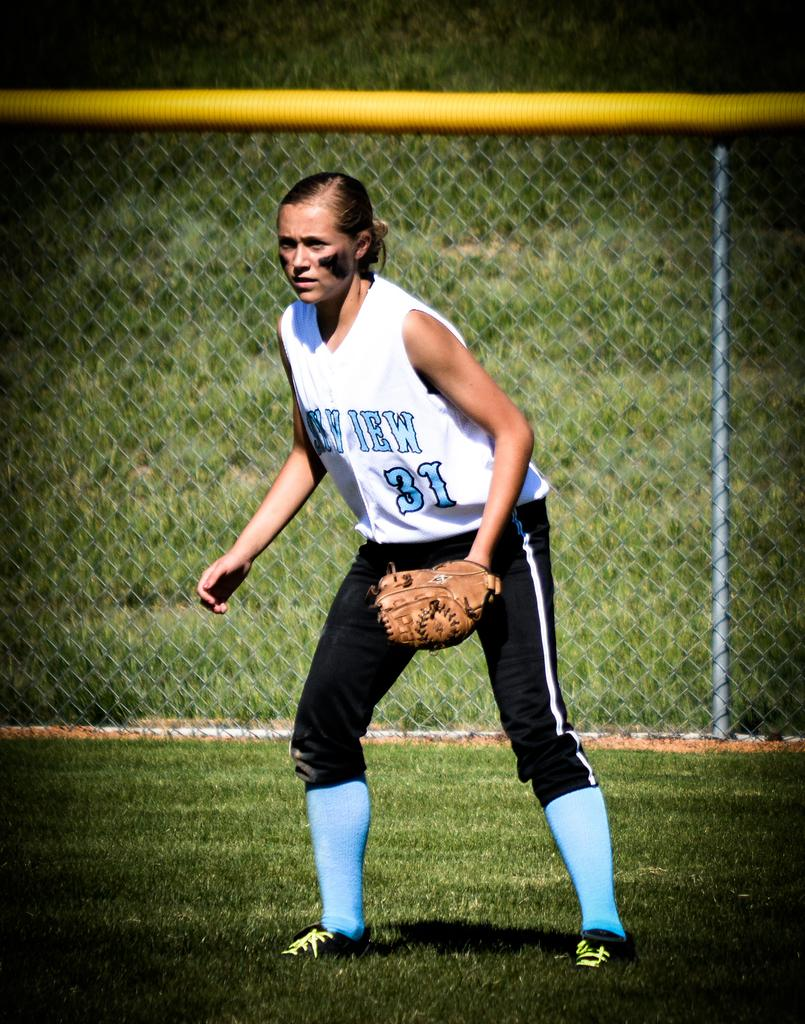<image>
Describe the image concisely. A female softball player with the number 31 is on a field holding a glove. 